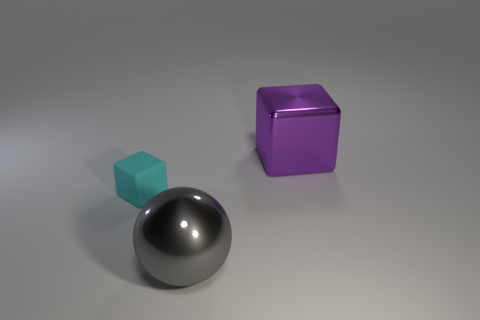Add 2 spheres. How many objects exist? 5 Subtract all blocks. How many objects are left? 1 Subtract all large gray balls. Subtract all large metallic balls. How many objects are left? 1 Add 2 big purple objects. How many big purple objects are left? 3 Add 2 small yellow metal balls. How many small yellow metal balls exist? 2 Subtract 1 purple cubes. How many objects are left? 2 